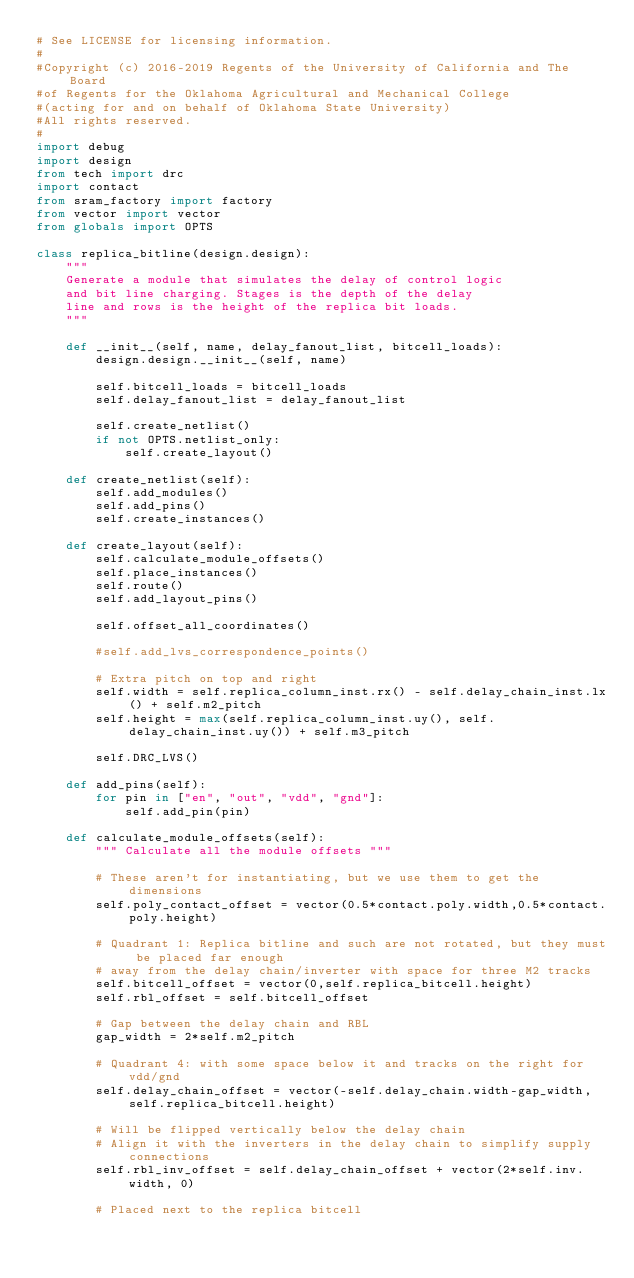<code> <loc_0><loc_0><loc_500><loc_500><_Python_># See LICENSE for licensing information.
#
#Copyright (c) 2016-2019 Regents of the University of California and The Board
#of Regents for the Oklahoma Agricultural and Mechanical College
#(acting for and on behalf of Oklahoma State University)
#All rights reserved.
#
import debug
import design
from tech import drc
import contact
from sram_factory import factory
from vector import vector
from globals import OPTS

class replica_bitline(design.design):
    """
    Generate a module that simulates the delay of control logic 
    and bit line charging. Stages is the depth of the delay
    line and rows is the height of the replica bit loads.
    """

    def __init__(self, name, delay_fanout_list, bitcell_loads):
        design.design.__init__(self, name)

        self.bitcell_loads = bitcell_loads
        self.delay_fanout_list = delay_fanout_list

        self.create_netlist()
        if not OPTS.netlist_only:
            self.create_layout()
            
    def create_netlist(self):
        self.add_modules()
        self.add_pins()
        self.create_instances()

    def create_layout(self):
        self.calculate_module_offsets()
        self.place_instances()
        self.route()
        self.add_layout_pins()

        self.offset_all_coordinates()

        #self.add_lvs_correspondence_points()

        # Extra pitch on top and right
        self.width = self.replica_column_inst.rx() - self.delay_chain_inst.lx() + self.m2_pitch
        self.height = max(self.replica_column_inst.uy(), self.delay_chain_inst.uy()) + self.m3_pitch

        self.DRC_LVS()

    def add_pins(self):
        for pin in ["en", "out", "vdd", "gnd"]:
            self.add_pin(pin)

    def calculate_module_offsets(self):
        """ Calculate all the module offsets """
        
        # These aren't for instantiating, but we use them to get the dimensions
        self.poly_contact_offset = vector(0.5*contact.poly.width,0.5*contact.poly.height)

        # Quadrant 1: Replica bitline and such are not rotated, but they must be placed far enough
        # away from the delay chain/inverter with space for three M2 tracks
        self.bitcell_offset = vector(0,self.replica_bitcell.height)
        self.rbl_offset = self.bitcell_offset 

        # Gap between the delay chain and RBL
        gap_width = 2*self.m2_pitch
        
        # Quadrant 4: with some space below it and tracks on the right for vdd/gnd
        self.delay_chain_offset = vector(-self.delay_chain.width-gap_width,self.replica_bitcell.height)
        
        # Will be flipped vertically below the delay chain
        # Align it with the inverters in the delay chain to simplify supply connections
        self.rbl_inv_offset = self.delay_chain_offset + vector(2*self.inv.width, 0)

        # Placed next to the replica bitcell</code> 